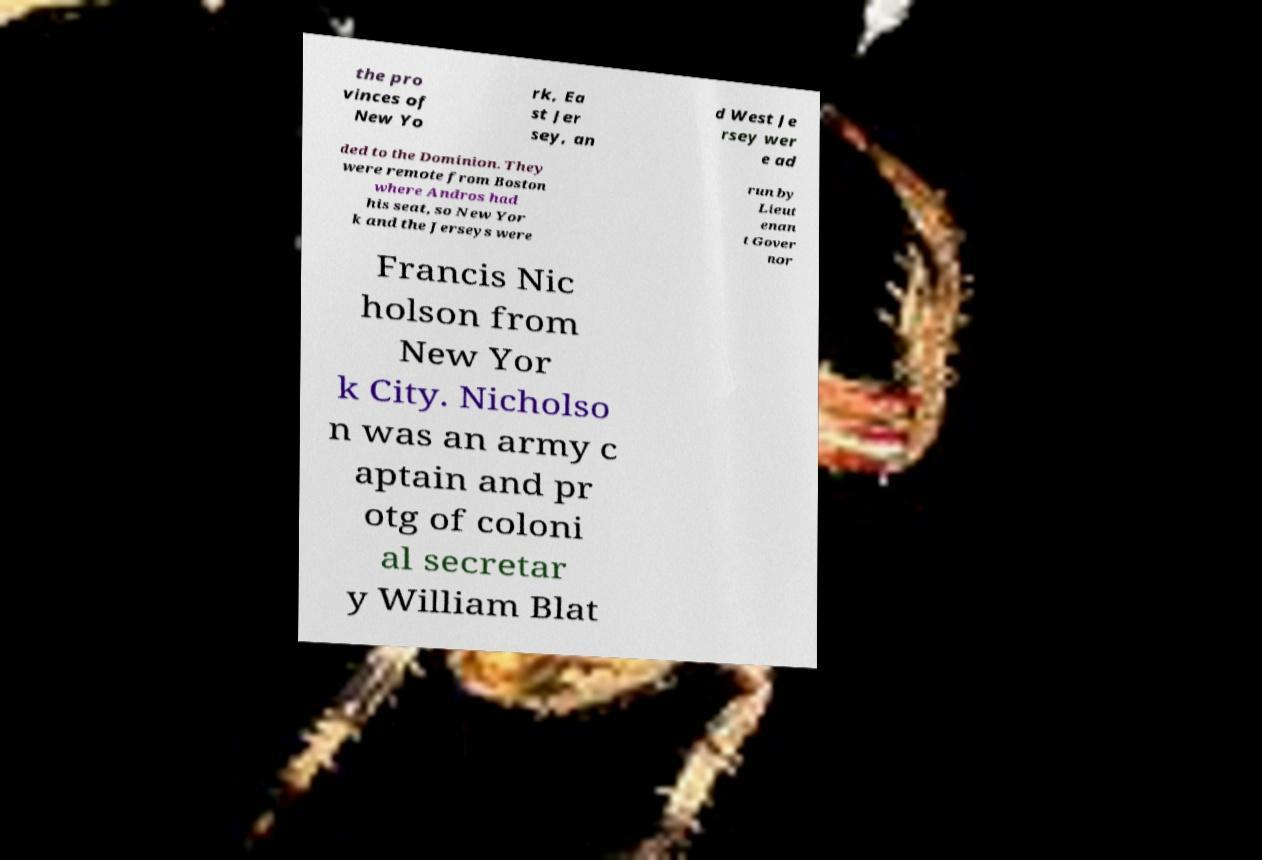Please read and relay the text visible in this image. What does it say? the pro vinces of New Yo rk, Ea st Jer sey, an d West Je rsey wer e ad ded to the Dominion. They were remote from Boston where Andros had his seat, so New Yor k and the Jerseys were run by Lieut enan t Gover nor Francis Nic holson from New Yor k City. Nicholso n was an army c aptain and pr otg of coloni al secretar y William Blat 